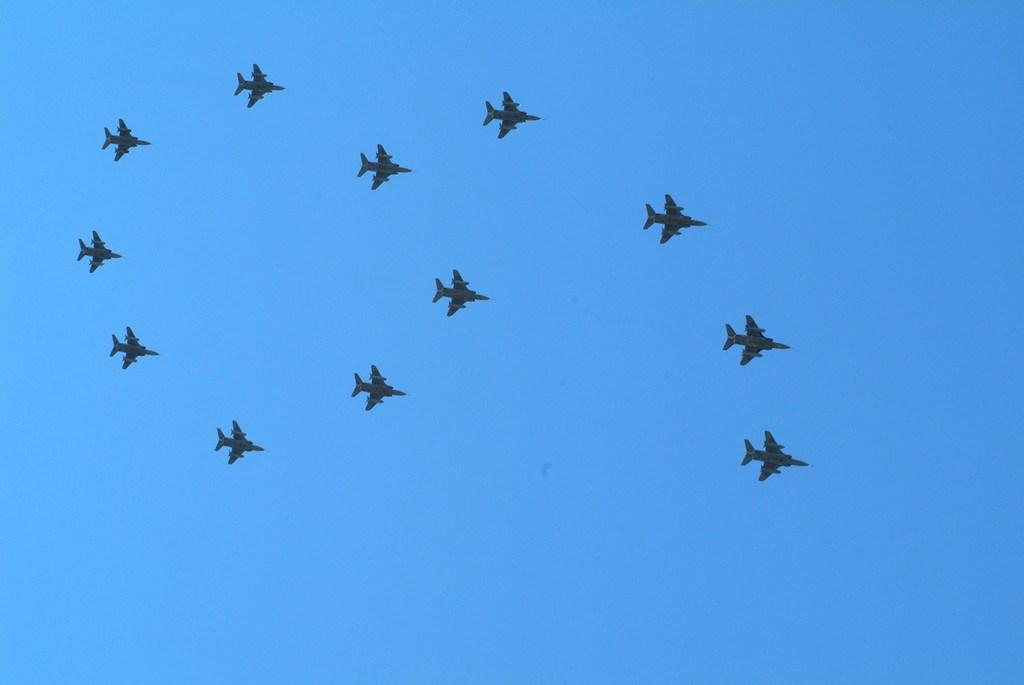What is the main subject of the image? The main subject of the image is aircraft. What are the aircraft doing in the image? The aircraft are flying in the air. What can be seen in the background of the image? There are clouds in the background of the image. What color is the sky in the image? The sky is blue in the image. What type of writing can be seen on the wings of the aircraft in the image? There is no writing visible on the wings of the aircraft in the image. 